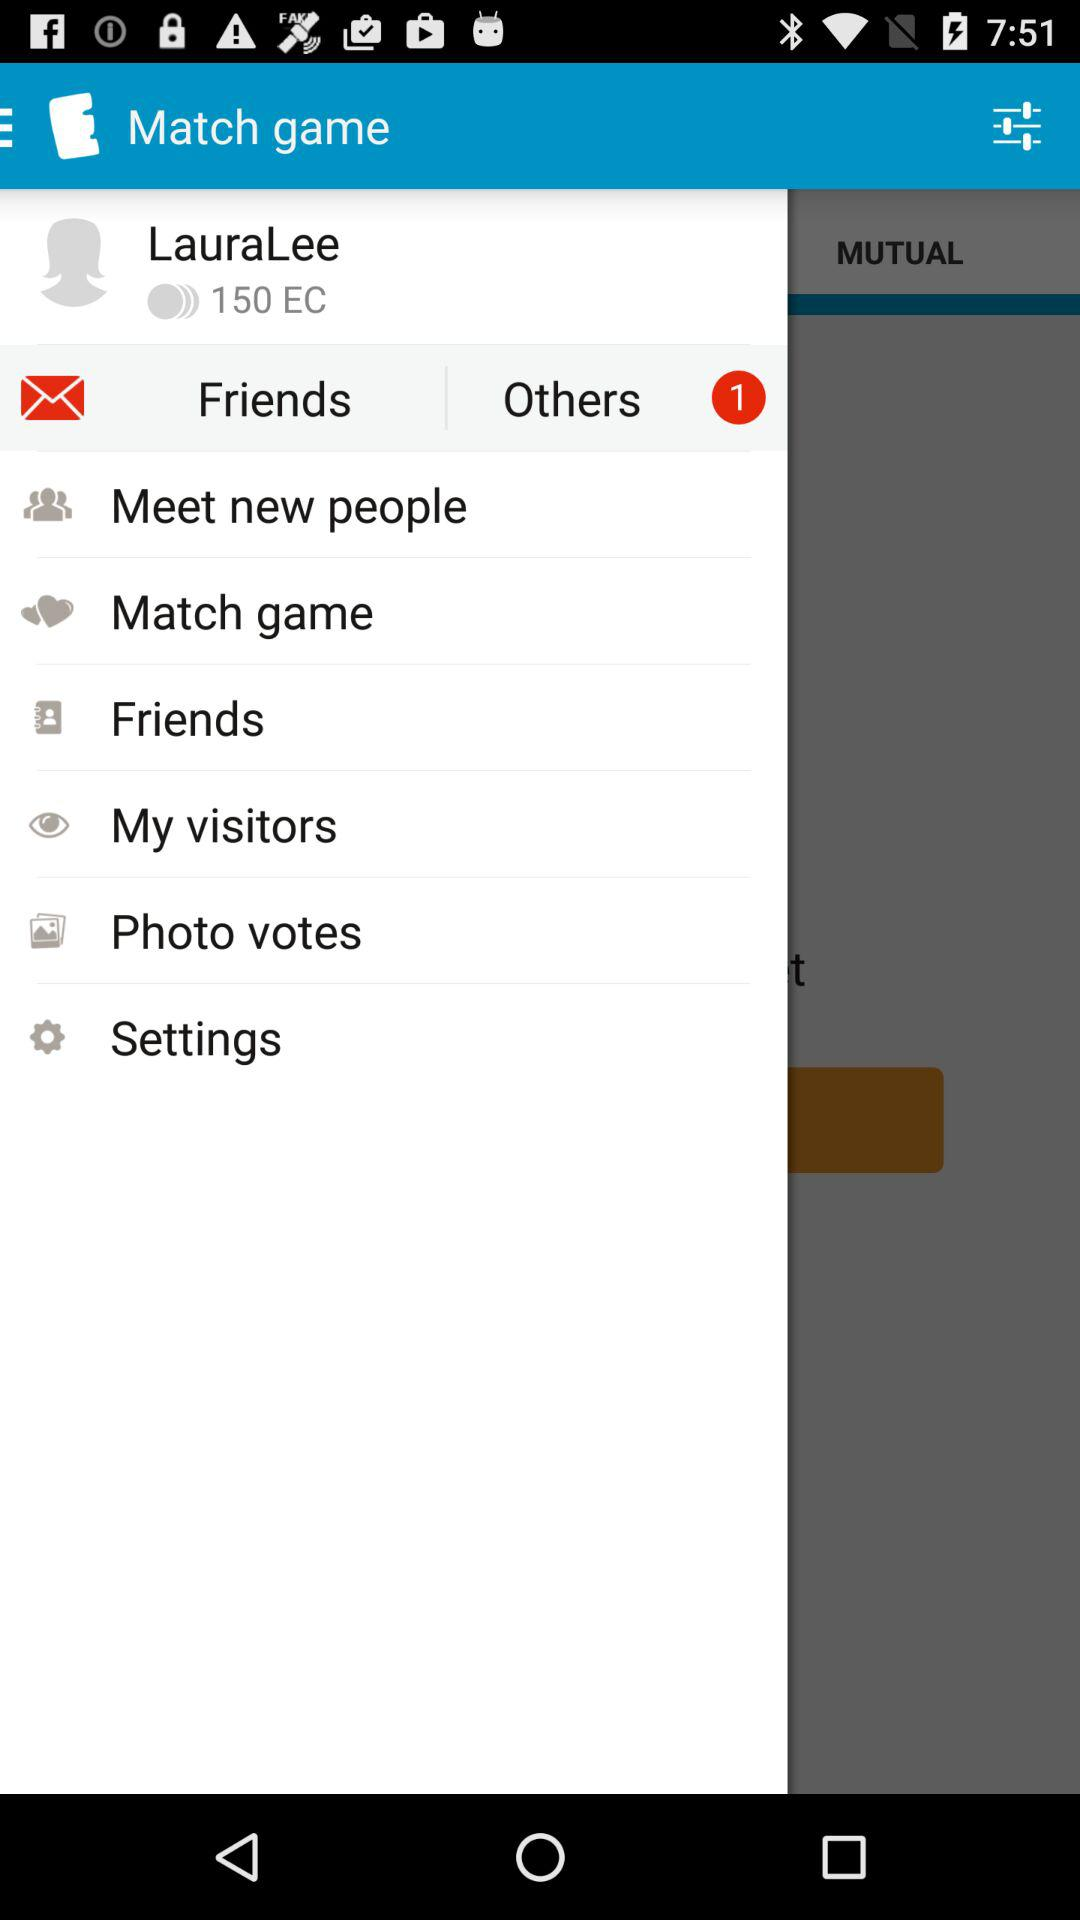How many EC in total are there? There are 150 EC in total. 